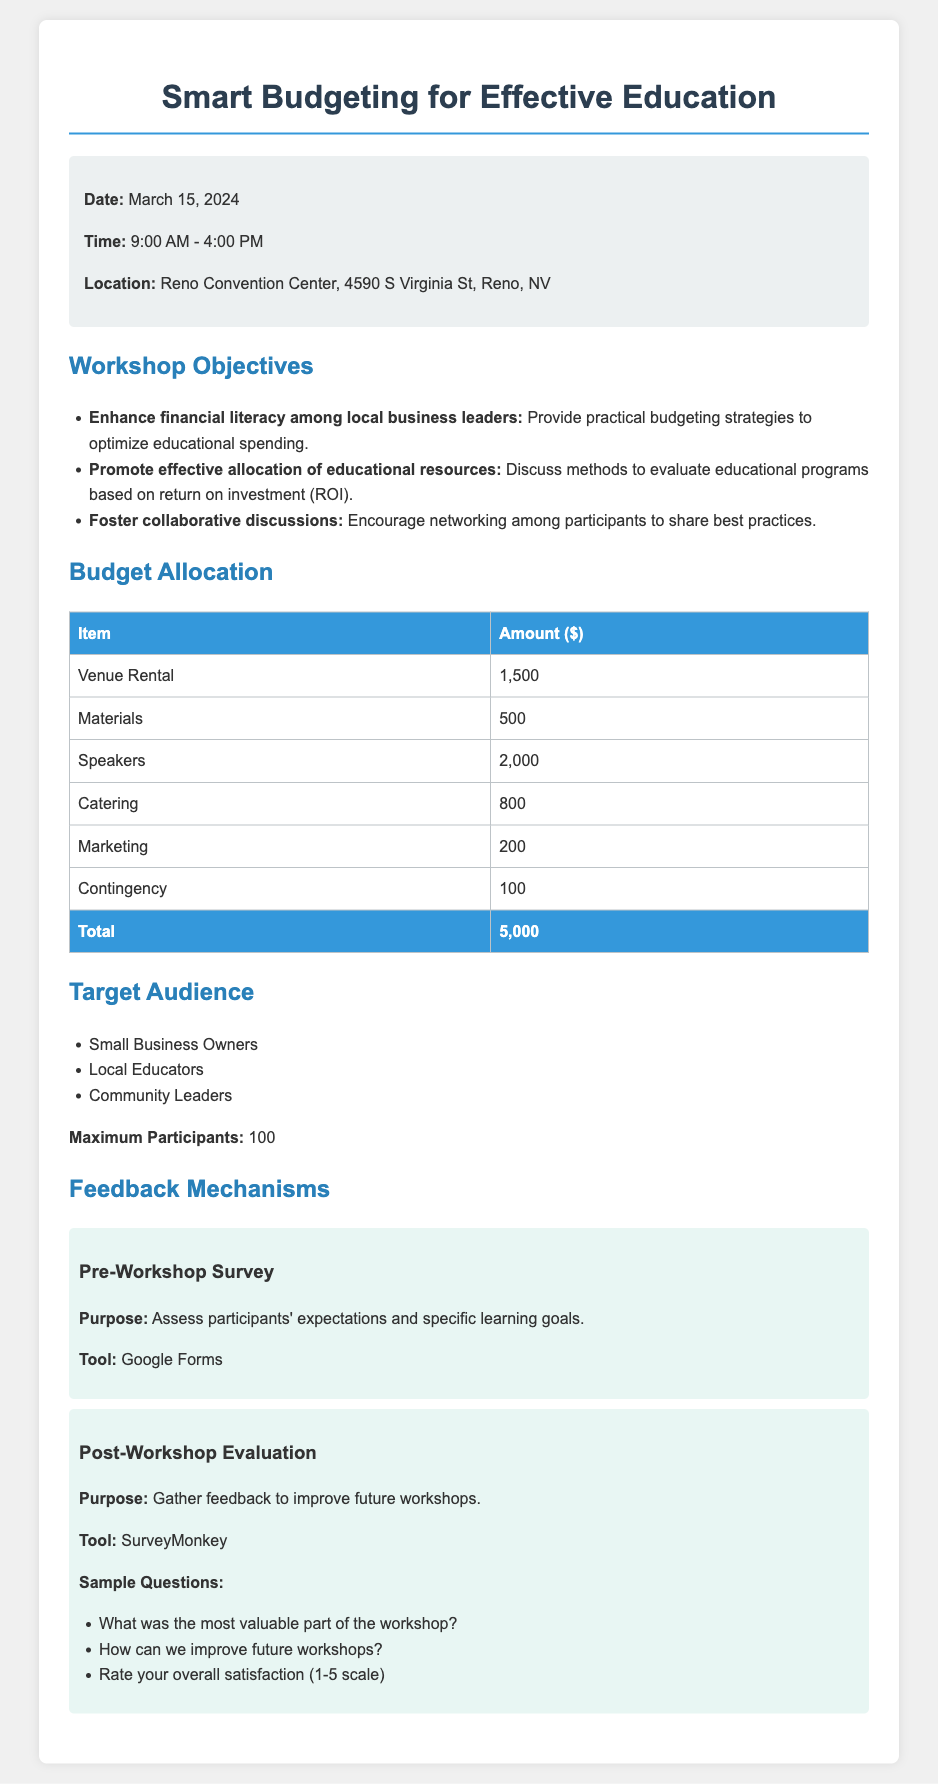What is the date of the workshop? The date of the workshop is specified in the document.
Answer: March 15, 2024 What is the total budget for the workshop? The total budget is presented in the budget allocation section of the document.
Answer: 5,000 How many maximum participants are allowed? The document states the maximum number of participants in the target audience section.
Answer: 100 What is one method discussed for evaluating educational programs? This involves reasoning about the workshop objectives that focus on educational resource allocation.
Answer: Return on investment What tool is used for the pre-workshop survey? The tool for the pre-workshop survey is mentioned in the feedback mechanisms section of the document.
Answer: Google Forms What is the amount allocated for catering? The budget table lists specific amounts for each item, including catering.
Answer: 800 Which location is hosting the workshop? The location of the workshop is detailed in the workshop information section.
Answer: Reno Convention Center What is the purpose of the post-workshop evaluation? The document outlines the purpose of the post-workshop evaluation in the feedback section.
Answer: Improve future workshops 